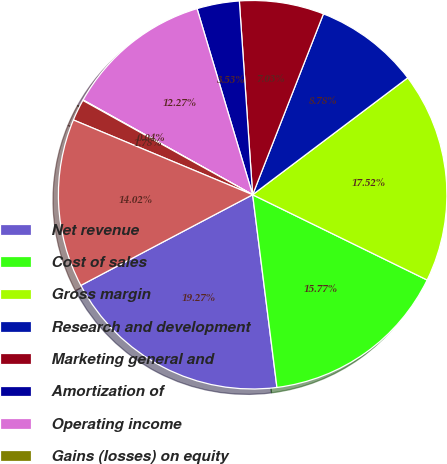Convert chart. <chart><loc_0><loc_0><loc_500><loc_500><pie_chart><fcel>Net revenue<fcel>Cost of sales<fcel>Gross margin<fcel>Research and development<fcel>Marketing general and<fcel>Amortization of<fcel>Operating income<fcel>Gains (losses) on equity<fcel>Interest and other net<fcel>Income before taxes<nl><fcel>19.27%<fcel>15.77%<fcel>17.52%<fcel>8.78%<fcel>7.03%<fcel>3.53%<fcel>12.27%<fcel>0.04%<fcel>1.78%<fcel>14.02%<nl></chart> 